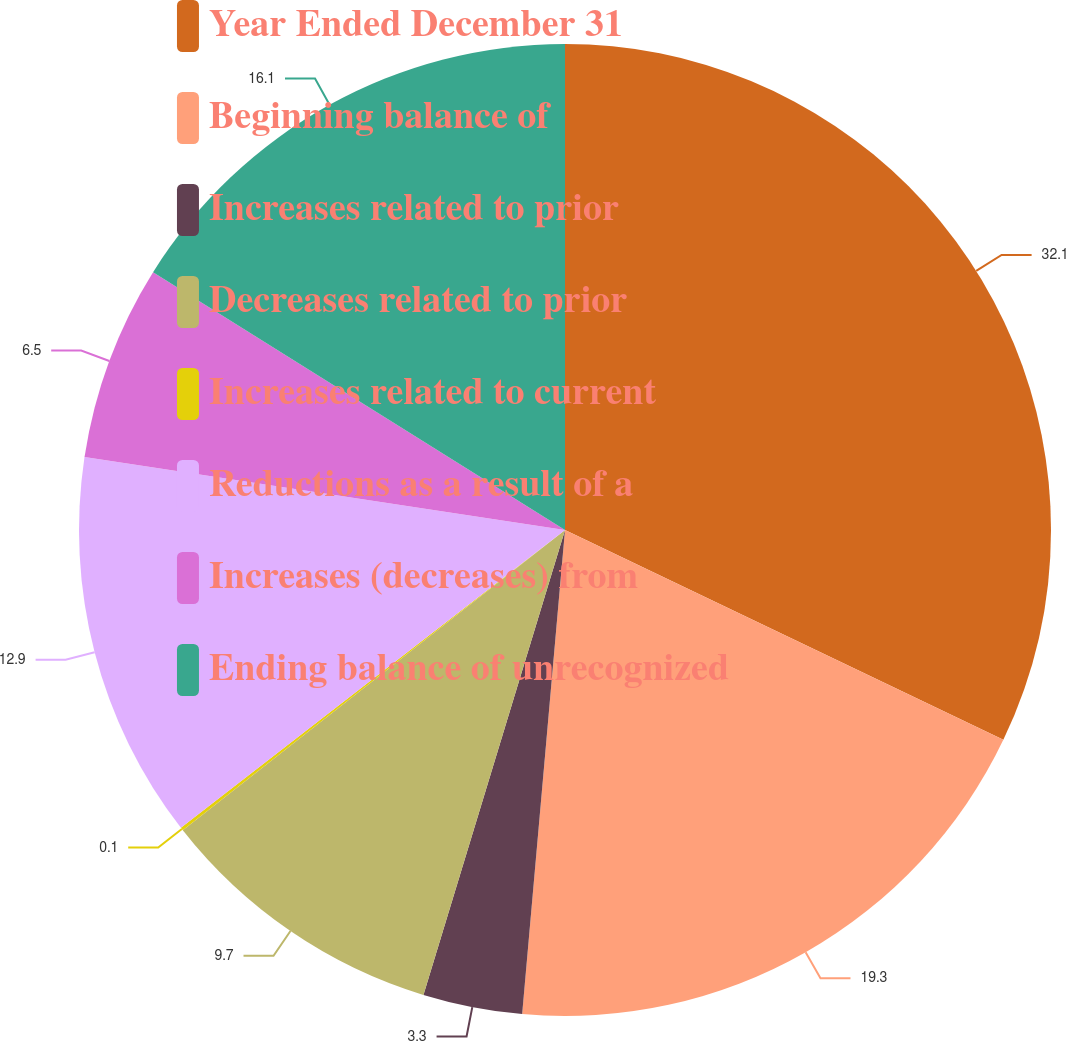Convert chart to OTSL. <chart><loc_0><loc_0><loc_500><loc_500><pie_chart><fcel>Year Ended December 31<fcel>Beginning balance of<fcel>Increases related to prior<fcel>Decreases related to prior<fcel>Increases related to current<fcel>Reductions as a result of a<fcel>Increases (decreases) from<fcel>Ending balance of unrecognized<nl><fcel>32.11%<fcel>19.3%<fcel>3.3%<fcel>9.7%<fcel>0.1%<fcel>12.9%<fcel>6.5%<fcel>16.1%<nl></chart> 